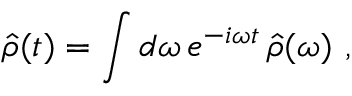Convert formula to latex. <formula><loc_0><loc_0><loc_500><loc_500>\hat { \rho } ( t ) = \int d \omega \, e ^ { - i \omega t } \, \hat { \rho } ( \omega ) ,</formula> 